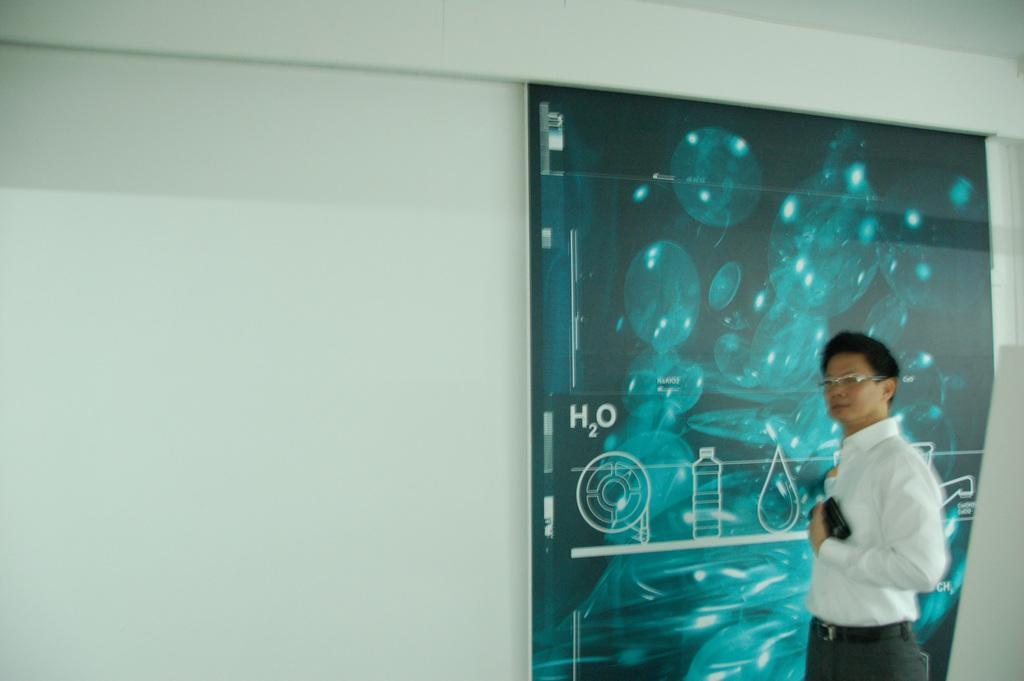Who or what is the main subject in the image? There is a person in the image. Can you describe the person's appearance? The person is wearing spectacles. What is the person holding in his hand? The person is holding an object in his hand, but the specific object is not mentioned in the facts. What can be seen on the wall in the background? There is a banner with text on the wall in the background? How much dust can be seen on the person's hand in the image? There is no mention of dust in the image, so it cannot be determined how much dust might be present on the person's hand. 